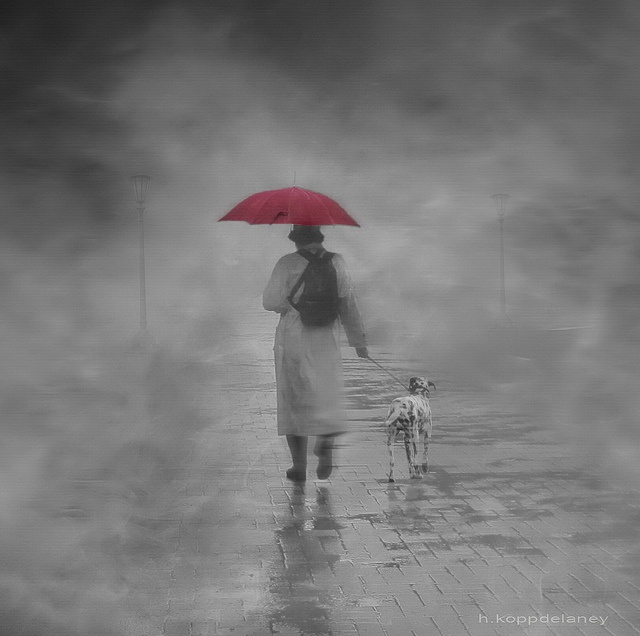Describe the objects in this image and their specific colors. I can see people in black, gray, and maroon tones, umbrella in black and brown tones, dog in black, darkgray, gray, and lightgray tones, and backpack in black and gray tones in this image. 